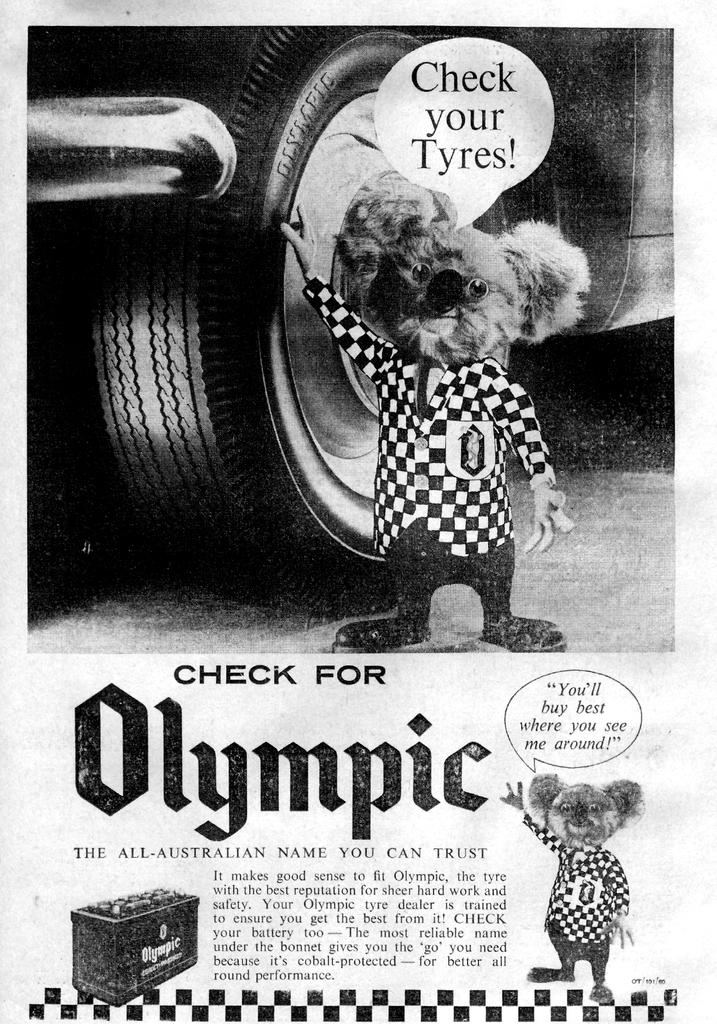What type of image is depicted in the picture? The image contains a black and white picture of a car. Where is the car located in the image? The car is parked on the road in the image. What object can be seen on the ground near the car? There is a doll placed on the ground near the car. What can be seen in the background of the image? There is some text visible in the background, as well as a box. What type of machine is being used to generate the belief in the image? There is no machine or belief present in the image; it features a black and white picture of a car, a doll, and some text and a box in the background. 